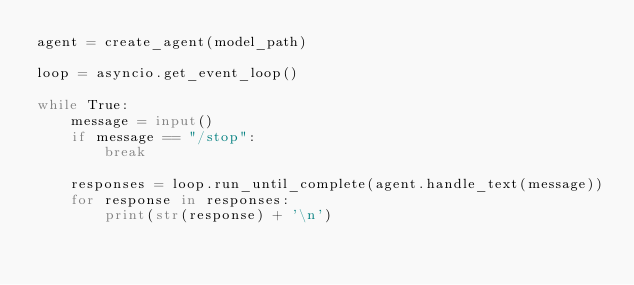<code> <loc_0><loc_0><loc_500><loc_500><_Python_>agent = create_agent(model_path)

loop = asyncio.get_event_loop()

while True:
    message = input()
    if message == "/stop":
        break

    responses = loop.run_until_complete(agent.handle_text(message))
    for response in responses:
        print(str(response) + '\n')
</code> 